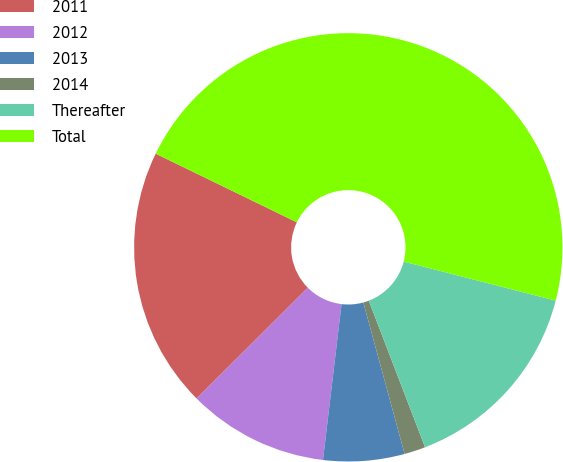Convert chart. <chart><loc_0><loc_0><loc_500><loc_500><pie_chart><fcel>2011<fcel>2012<fcel>2013<fcel>2014<fcel>Thereafter<fcel>Total<nl><fcel>19.68%<fcel>10.64%<fcel>6.12%<fcel>1.6%<fcel>15.16%<fcel>46.8%<nl></chart> 